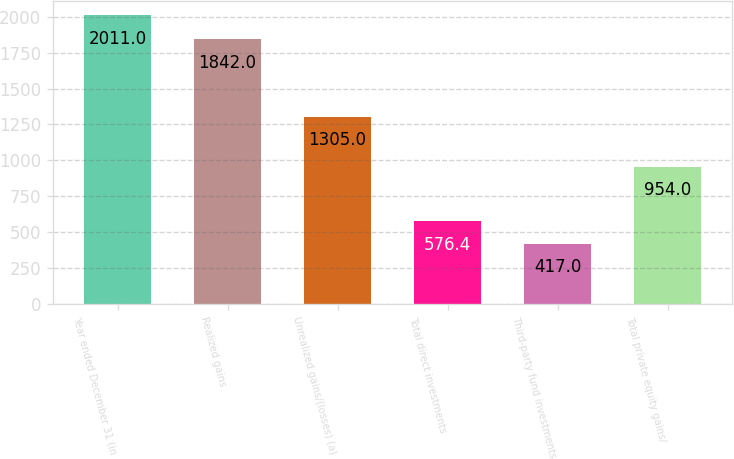<chart> <loc_0><loc_0><loc_500><loc_500><bar_chart><fcel>Year ended December 31 (in<fcel>Realized gains<fcel>Unrealized gains/(losses) (a)<fcel>Total direct investments<fcel>Third-party fund investments<fcel>Total private equity gains/<nl><fcel>2011<fcel>1842<fcel>1305<fcel>576.4<fcel>417<fcel>954<nl></chart> 